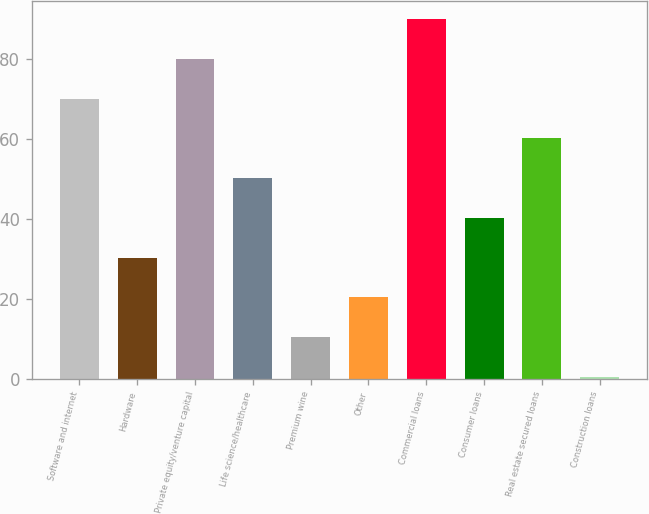Convert chart to OTSL. <chart><loc_0><loc_0><loc_500><loc_500><bar_chart><fcel>Software and internet<fcel>Hardware<fcel>Private equity/venture capital<fcel>Life science/healthcare<fcel>Premium wine<fcel>Other<fcel>Commercial loans<fcel>Consumer loans<fcel>Real estate secured loans<fcel>Construction loans<nl><fcel>70.15<fcel>30.35<fcel>80.1<fcel>50.25<fcel>10.45<fcel>20.4<fcel>90.05<fcel>40.3<fcel>60.2<fcel>0.5<nl></chart> 